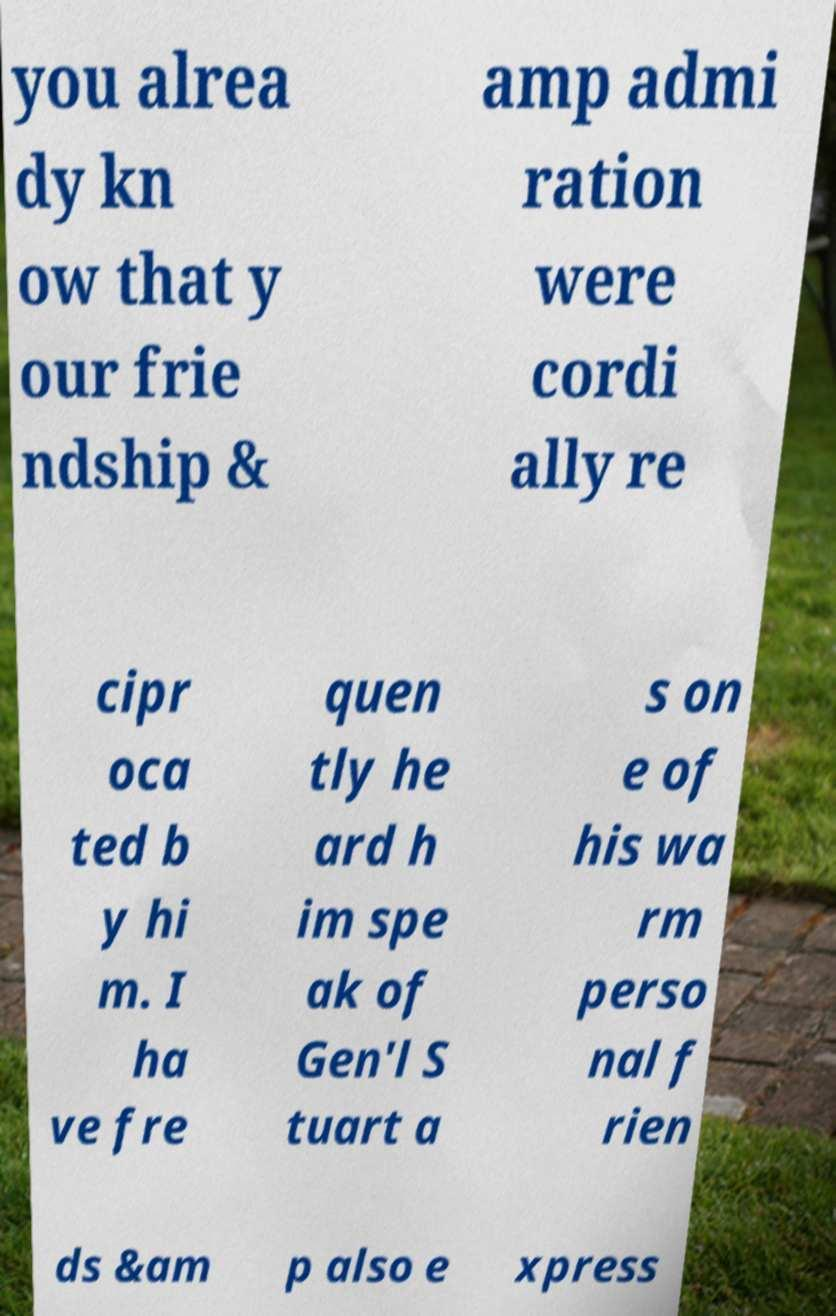For documentation purposes, I need the text within this image transcribed. Could you provide that? you alrea dy kn ow that y our frie ndship & amp admi ration were cordi ally re cipr oca ted b y hi m. I ha ve fre quen tly he ard h im spe ak of Gen'l S tuart a s on e of his wa rm perso nal f rien ds &am p also e xpress 